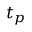Convert formula to latex. <formula><loc_0><loc_0><loc_500><loc_500>t _ { p }</formula> 